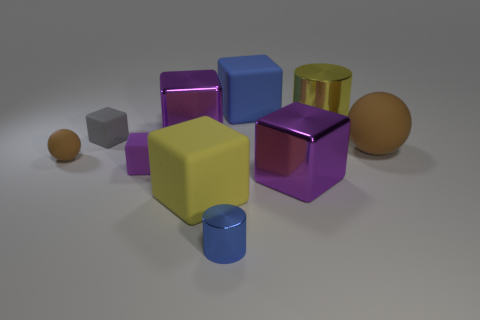How many purple blocks must be subtracted to get 1 purple blocks? 2 Subtract all yellow cubes. How many cubes are left? 5 Subtract 2 balls. How many balls are left? 0 Subtract all yellow blocks. How many blocks are left? 5 Subtract all yellow cubes. How many yellow balls are left? 0 Subtract 0 green balls. How many objects are left? 10 Subtract all spheres. How many objects are left? 8 Subtract all cyan cubes. Subtract all purple cylinders. How many cubes are left? 6 Subtract all blue spheres. Subtract all tiny cylinders. How many objects are left? 9 Add 8 big yellow matte blocks. How many big yellow matte blocks are left? 9 